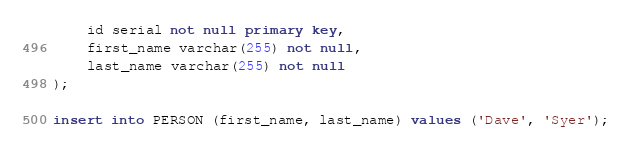<code> <loc_0><loc_0><loc_500><loc_500><_SQL_>	id serial not null primary key,
	first_name varchar(255) not null,
	last_name varchar(255) not null
);

insert into PERSON (first_name, last_name) values ('Dave', 'Syer');
</code> 